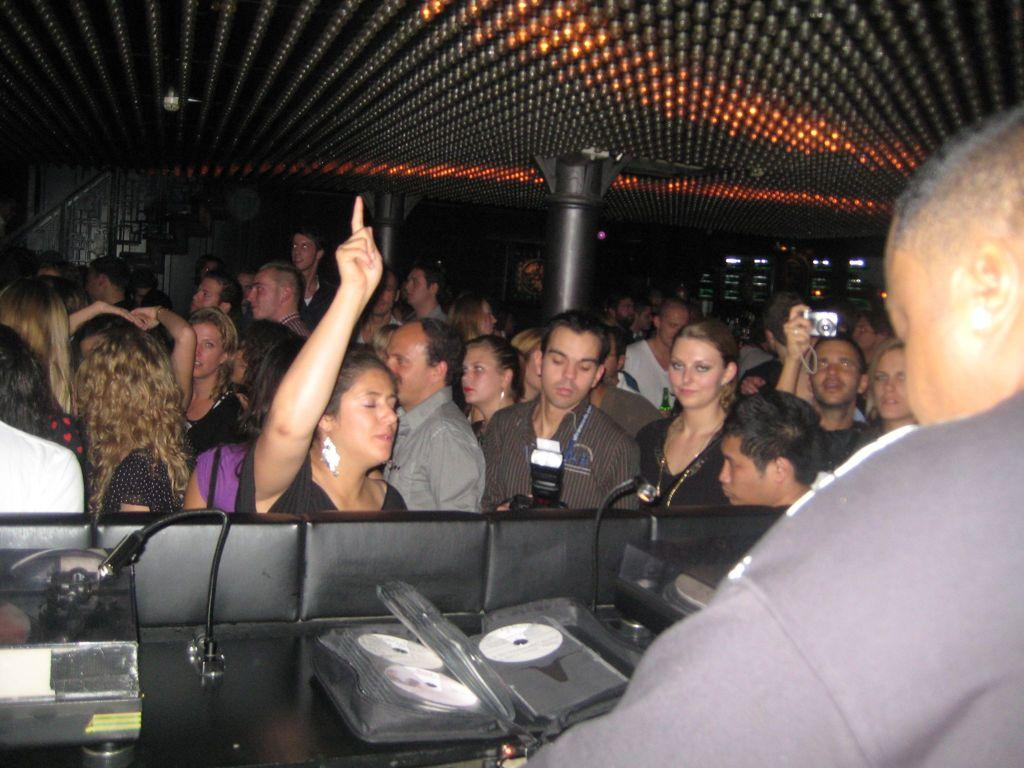What are the people in the image doing? The people in the image are standing on the floor. Can you describe what one person is holding? One person is holding a camera in their hands. What type of architectural feature can be seen in the image? There is a staircase in the image. What safety feature is present in the image? Railings are present in the image. What other objects can be seen in the image? Poles, a mic, and discs are visible in the image. What type of gun is being used by the person holding the quill in the image? There is no gun or quill present in the image. How does the acoustics of the room affect the sound quality of the discs in the image? The provided facts do not mention anything about the acoustics of the room, so it is impossible to determine how it affects the sound quality of the discs. 